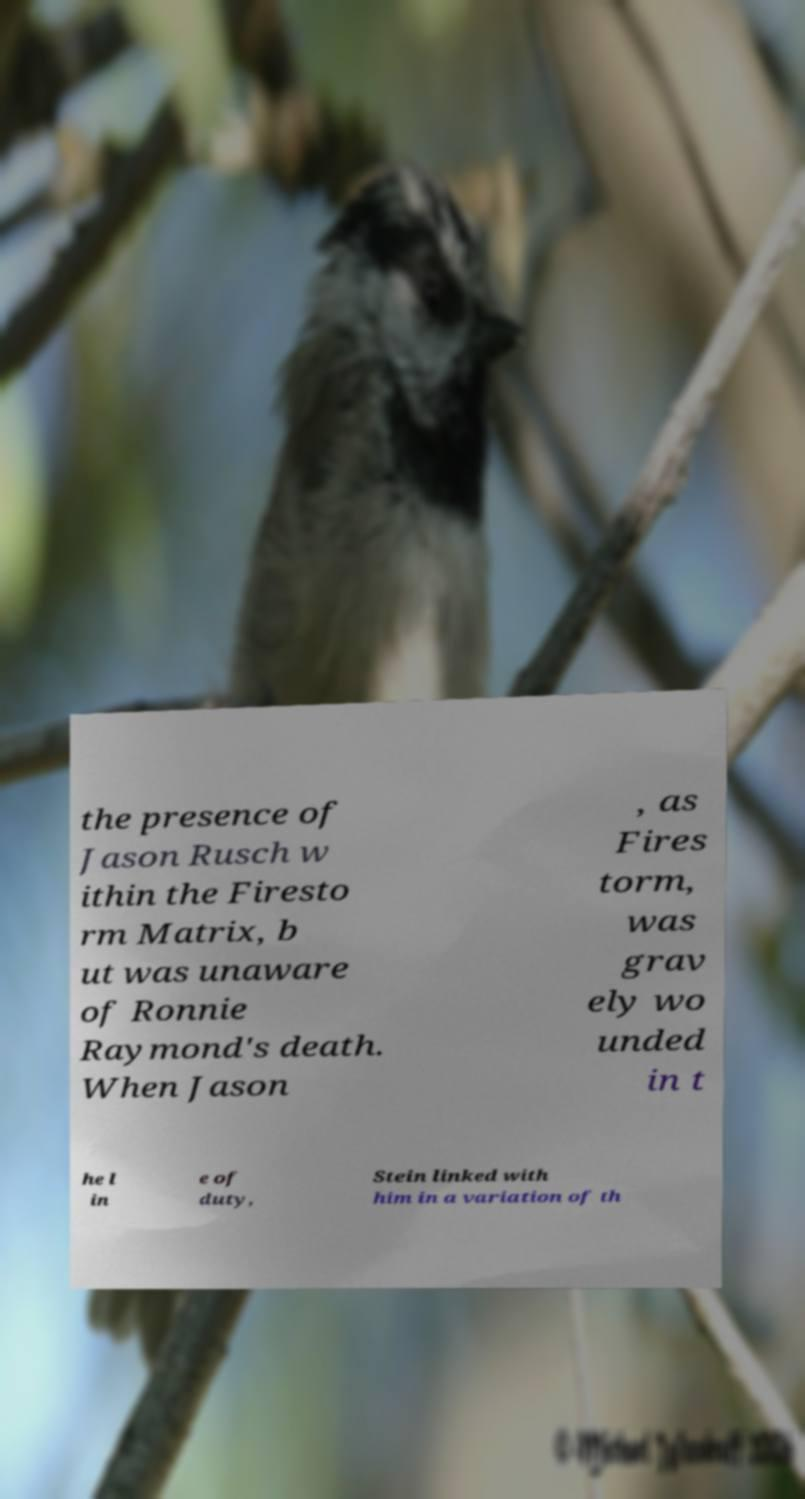For documentation purposes, I need the text within this image transcribed. Could you provide that? the presence of Jason Rusch w ithin the Firesto rm Matrix, b ut was unaware of Ronnie Raymond's death. When Jason , as Fires torm, was grav ely wo unded in t he l in e of duty, Stein linked with him in a variation of th 